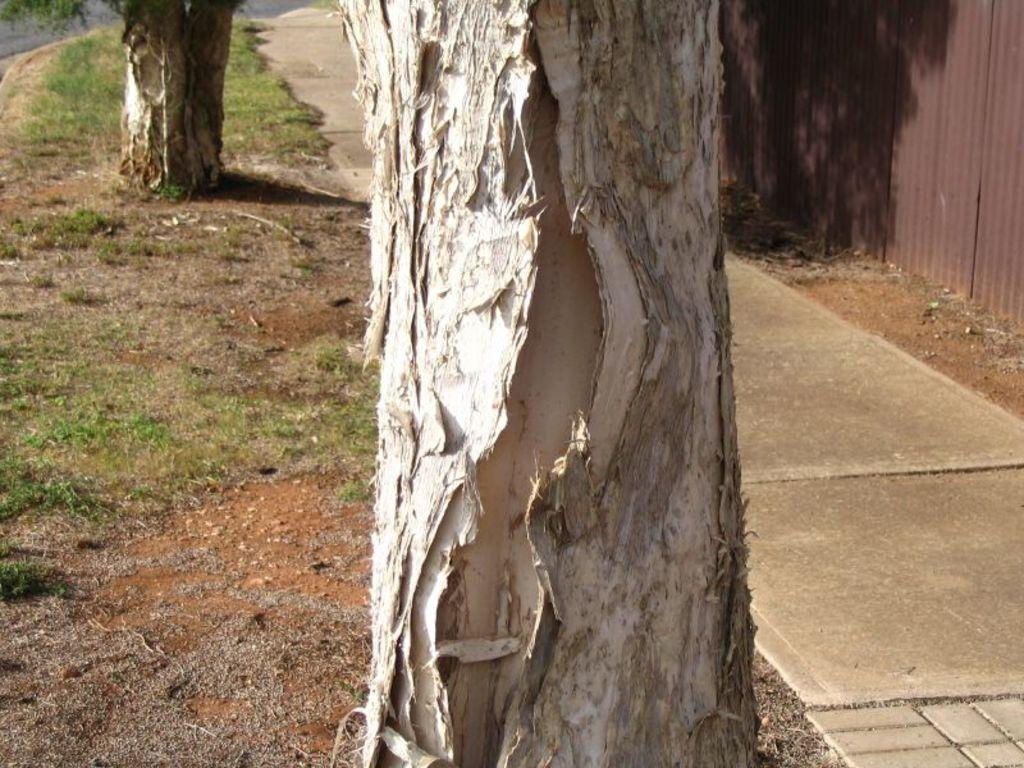What is the main subject in the middle of the image? There is a bark of a tree in the middle of the image. What type of material is used for the wall on the right side of the image? There is an iron sheet wall on the right side of the image. What type of drug is being sold on the bark of the tree in the image? There is no indication of any drug being sold or present in the image; it features a bark of a tree and an iron sheet wall. What type of trouble is depicted in the image? There is no depiction of trouble in the image; it features a bark of a tree and an iron sheet wall. 